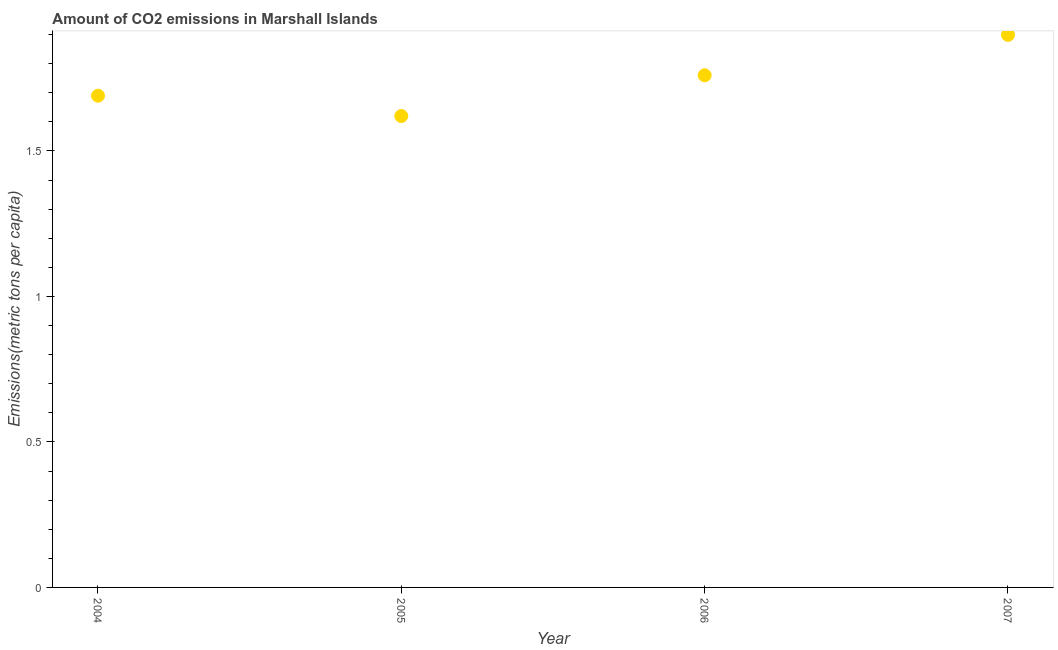What is the amount of co2 emissions in 2007?
Your response must be concise. 1.9. Across all years, what is the maximum amount of co2 emissions?
Make the answer very short. 1.9. Across all years, what is the minimum amount of co2 emissions?
Your response must be concise. 1.62. What is the sum of the amount of co2 emissions?
Your answer should be very brief. 6.97. What is the difference between the amount of co2 emissions in 2004 and 2005?
Give a very brief answer. 0.07. What is the average amount of co2 emissions per year?
Your answer should be compact. 1.74. What is the median amount of co2 emissions?
Keep it short and to the point. 1.73. Do a majority of the years between 2007 and 2006 (inclusive) have amount of co2 emissions greater than 1.7 metric tons per capita?
Give a very brief answer. No. What is the ratio of the amount of co2 emissions in 2004 to that in 2006?
Give a very brief answer. 0.96. Is the difference between the amount of co2 emissions in 2005 and 2007 greater than the difference between any two years?
Make the answer very short. Yes. What is the difference between the highest and the second highest amount of co2 emissions?
Provide a short and direct response. 0.14. Is the sum of the amount of co2 emissions in 2005 and 2007 greater than the maximum amount of co2 emissions across all years?
Give a very brief answer. Yes. What is the difference between the highest and the lowest amount of co2 emissions?
Provide a succinct answer. 0.28. In how many years, is the amount of co2 emissions greater than the average amount of co2 emissions taken over all years?
Your answer should be compact. 2. Does the amount of co2 emissions monotonically increase over the years?
Offer a very short reply. No. How many years are there in the graph?
Provide a short and direct response. 4. Are the values on the major ticks of Y-axis written in scientific E-notation?
Your response must be concise. No. Does the graph contain grids?
Keep it short and to the point. No. What is the title of the graph?
Give a very brief answer. Amount of CO2 emissions in Marshall Islands. What is the label or title of the Y-axis?
Your response must be concise. Emissions(metric tons per capita). What is the Emissions(metric tons per capita) in 2004?
Give a very brief answer. 1.69. What is the Emissions(metric tons per capita) in 2005?
Your answer should be compact. 1.62. What is the Emissions(metric tons per capita) in 2006?
Your answer should be very brief. 1.76. What is the Emissions(metric tons per capita) in 2007?
Your response must be concise. 1.9. What is the difference between the Emissions(metric tons per capita) in 2004 and 2005?
Your response must be concise. 0.07. What is the difference between the Emissions(metric tons per capita) in 2004 and 2006?
Your answer should be very brief. -0.07. What is the difference between the Emissions(metric tons per capita) in 2004 and 2007?
Ensure brevity in your answer.  -0.21. What is the difference between the Emissions(metric tons per capita) in 2005 and 2006?
Provide a succinct answer. -0.14. What is the difference between the Emissions(metric tons per capita) in 2005 and 2007?
Offer a very short reply. -0.28. What is the difference between the Emissions(metric tons per capita) in 2006 and 2007?
Offer a very short reply. -0.14. What is the ratio of the Emissions(metric tons per capita) in 2004 to that in 2005?
Provide a succinct answer. 1.04. What is the ratio of the Emissions(metric tons per capita) in 2004 to that in 2007?
Your response must be concise. 0.89. What is the ratio of the Emissions(metric tons per capita) in 2005 to that in 2006?
Provide a short and direct response. 0.92. What is the ratio of the Emissions(metric tons per capita) in 2005 to that in 2007?
Offer a very short reply. 0.85. What is the ratio of the Emissions(metric tons per capita) in 2006 to that in 2007?
Offer a very short reply. 0.93. 